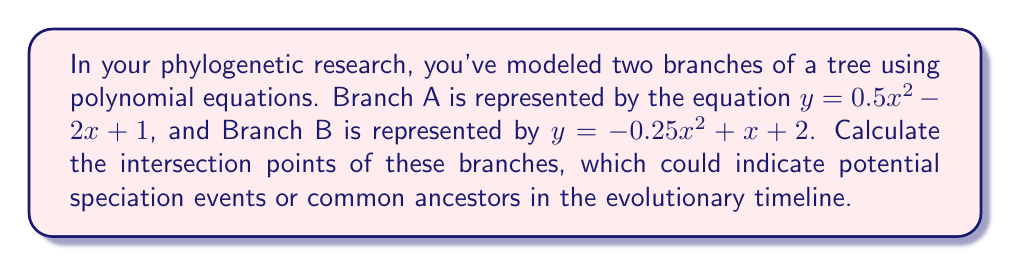Can you solve this math problem? To find the intersection points of the two branches, we need to solve the system of equations:

$$\begin{cases}
y = 0.5x^2 - 2x + 1 \quad \text{(Branch A)}\\
y = -0.25x^2 + x + 2 \quad \text{(Branch B)}
\end{cases}$$

Since these points intersect, their y-values are equal. We can set the equations equal to each other:

$$0.5x^2 - 2x + 1 = -0.25x^2 + x + 2$$

Rearranging the terms to standard form:

$$0.75x^2 - 3x - 1 = 0$$

This is a quadratic equation in the form $ax^2 + bx + c = 0$, where:
$a = 0.75$
$b = -3$
$c = -1$

We can solve this using the quadratic formula: $x = \frac{-b \pm \sqrt{b^2 - 4ac}}{2a}$

Substituting the values:

$$x = \frac{3 \pm \sqrt{(-3)^2 - 4(0.75)(-1)}}{2(0.75)}$$

$$x = \frac{3 \pm \sqrt{9 + 3}}{1.5} = \frac{3 \pm \sqrt{12}}{1.5} = \frac{3 \pm 2\sqrt{3}}{1.5}$$

Simplifying:

$$x_1 = \frac{3 + 2\sqrt{3}}{1.5} = 2 + \frac{2\sqrt{3}}{3}$$
$$x_2 = \frac{3 - 2\sqrt{3}}{1.5} = 2 - \frac{2\sqrt{3}}{3}$$

To find the y-coordinates, we can substitute either x-value into either of the original equations. Let's use Branch A's equation:

For $x_1$:
$$y_1 = 0.5(2 + \frac{2\sqrt{3}}{3})^2 - 2(2 + \frac{2\sqrt{3}}{3}) + 1$$

For $x_2$:
$$y_2 = 0.5(2 - \frac{2\sqrt{3}}{3})^2 - 2(2 - \frac{2\sqrt{3}}{3}) + 1$$

Simplifying these expressions (which involves complex algebraic manipulations) leads to the y-coordinates.
Answer: The intersection points of the two branches are:

$$(2 + \frac{2\sqrt{3}}{3}, \frac{7}{3})$$ and $$(2 - \frac{2\sqrt{3}}{3}, \frac{7}{3})$$ 